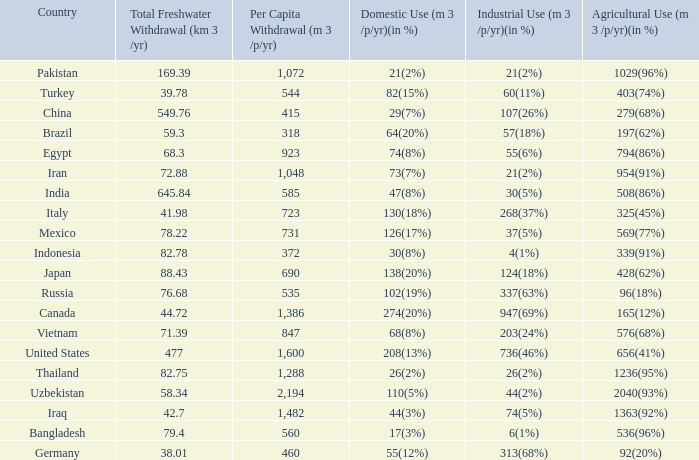What is Agricultural Use (m 3 /p/yr)(in %), when Per Capita Withdrawal (m 3 /p/yr) is greater than 923, and when Domestic Use (m 3 /p/yr)(in %) is 73(7%)? 954(91%). 